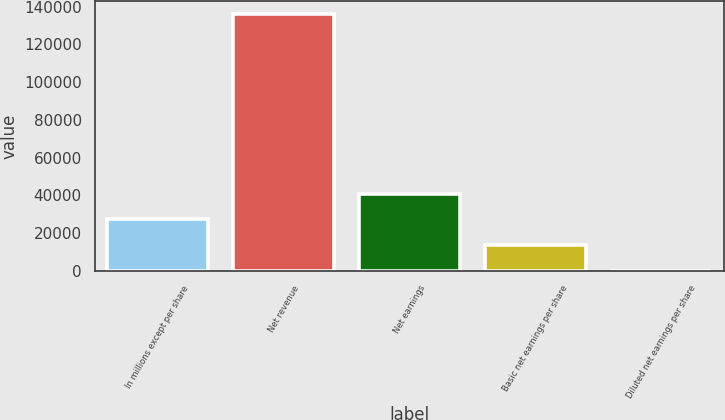Convert chart to OTSL. <chart><loc_0><loc_0><loc_500><loc_500><bar_chart><fcel>In millions except per share<fcel>Net revenue<fcel>Net earnings<fcel>Basic net earnings per share<fcel>Diluted net earnings per share<nl><fcel>27206.8<fcel>136022<fcel>40808.8<fcel>13605<fcel>3.05<nl></chart> 